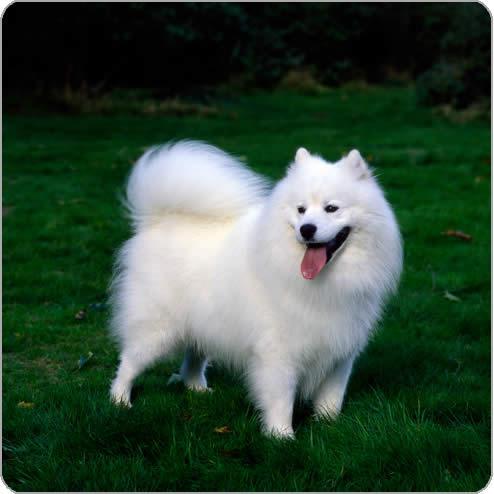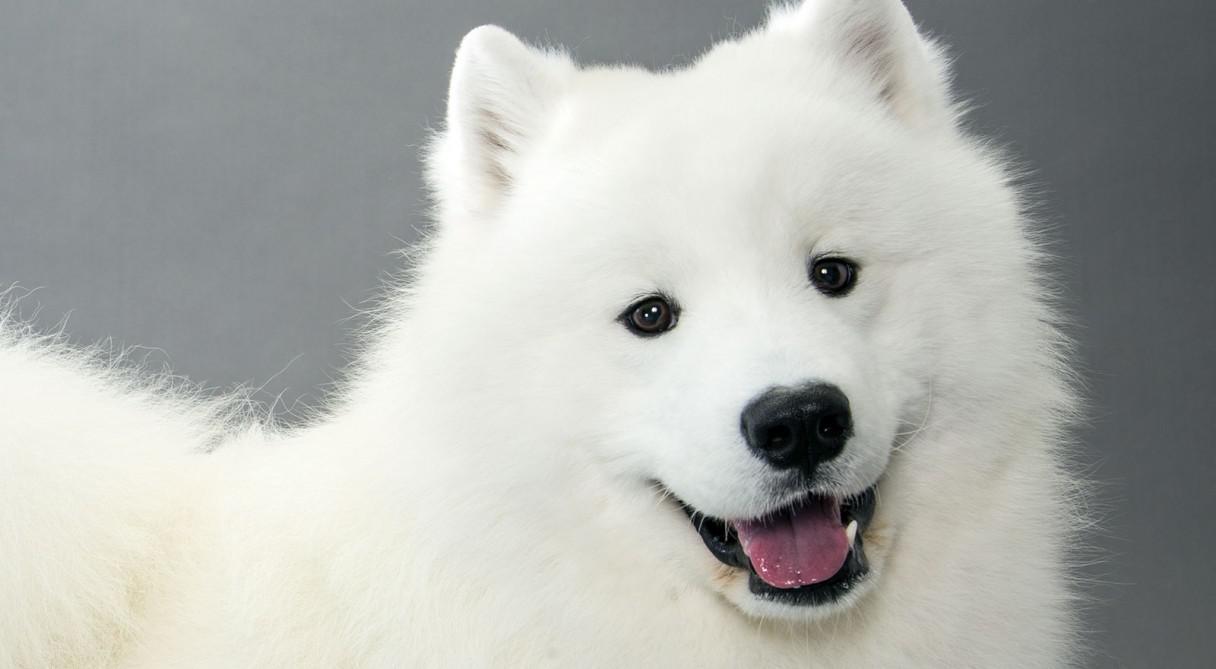The first image is the image on the left, the second image is the image on the right. Given the left and right images, does the statement "At least two dogs have have visible tongues." hold true? Answer yes or no. Yes. 